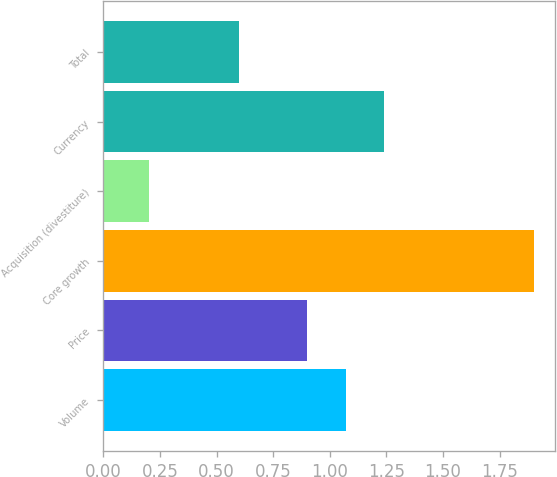Convert chart to OTSL. <chart><loc_0><loc_0><loc_500><loc_500><bar_chart><fcel>Volume<fcel>Price<fcel>Core growth<fcel>Acquisition (divestiture)<fcel>Currency<fcel>Total<nl><fcel>1.07<fcel>0.9<fcel>1.9<fcel>0.2<fcel>1.24<fcel>0.6<nl></chart> 